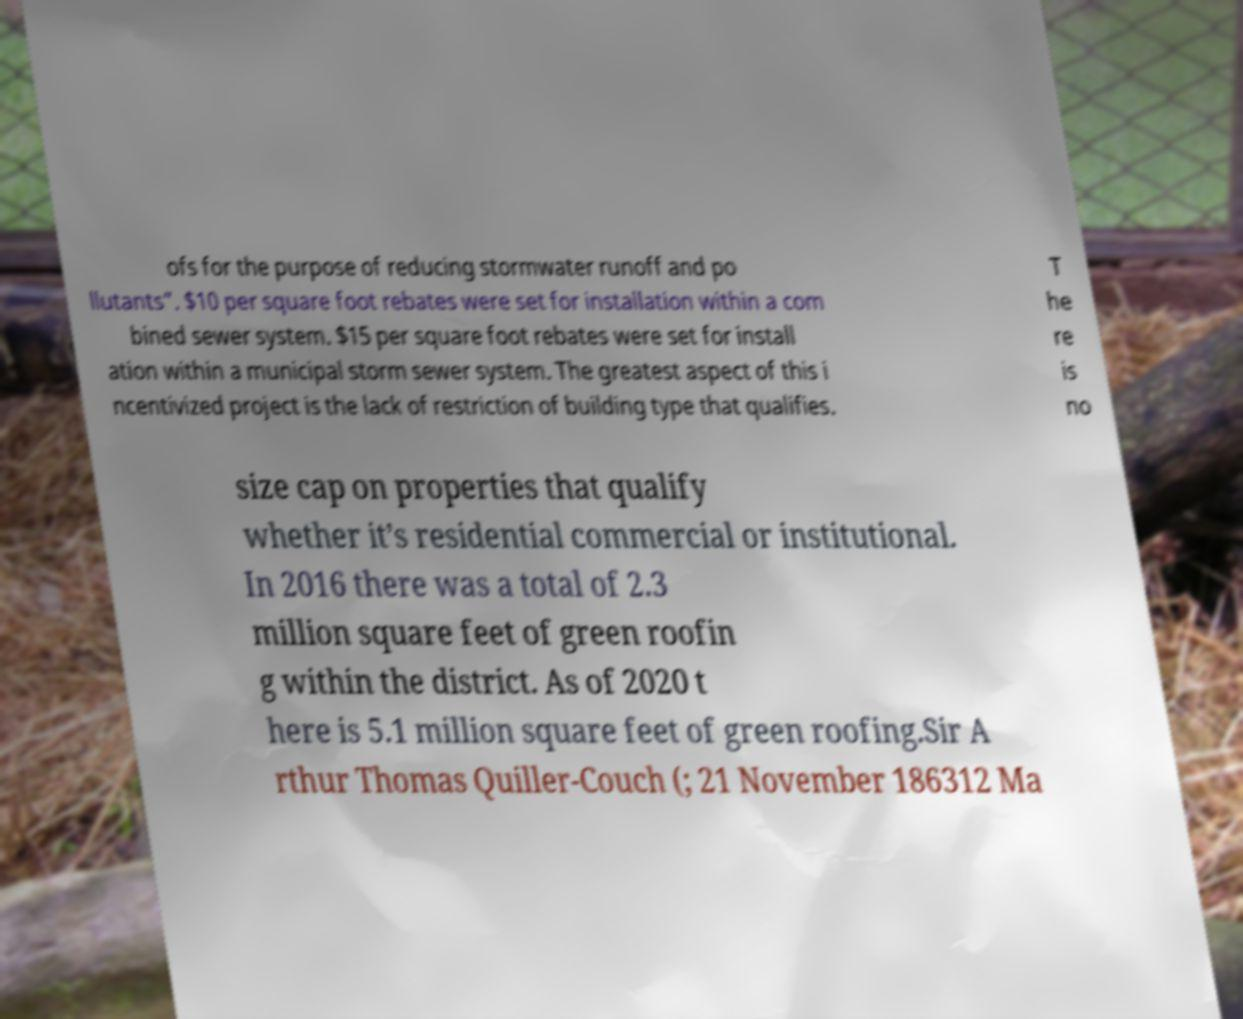Could you assist in decoding the text presented in this image and type it out clearly? ofs for the purpose of reducing stormwater runoff and po llutants”. $10 per square foot rebates were set for installation within a com bined sewer system. $15 per square foot rebates were set for install ation within a municipal storm sewer system. The greatest aspect of this i ncentivized project is the lack of restriction of building type that qualifies. T he re is no size cap on properties that qualify whether it’s residential commercial or institutional. In 2016 there was a total of 2.3 million square feet of green roofin g within the district. As of 2020 t here is 5.1 million square feet of green roofing.Sir A rthur Thomas Quiller-Couch (; 21 November 186312 Ma 